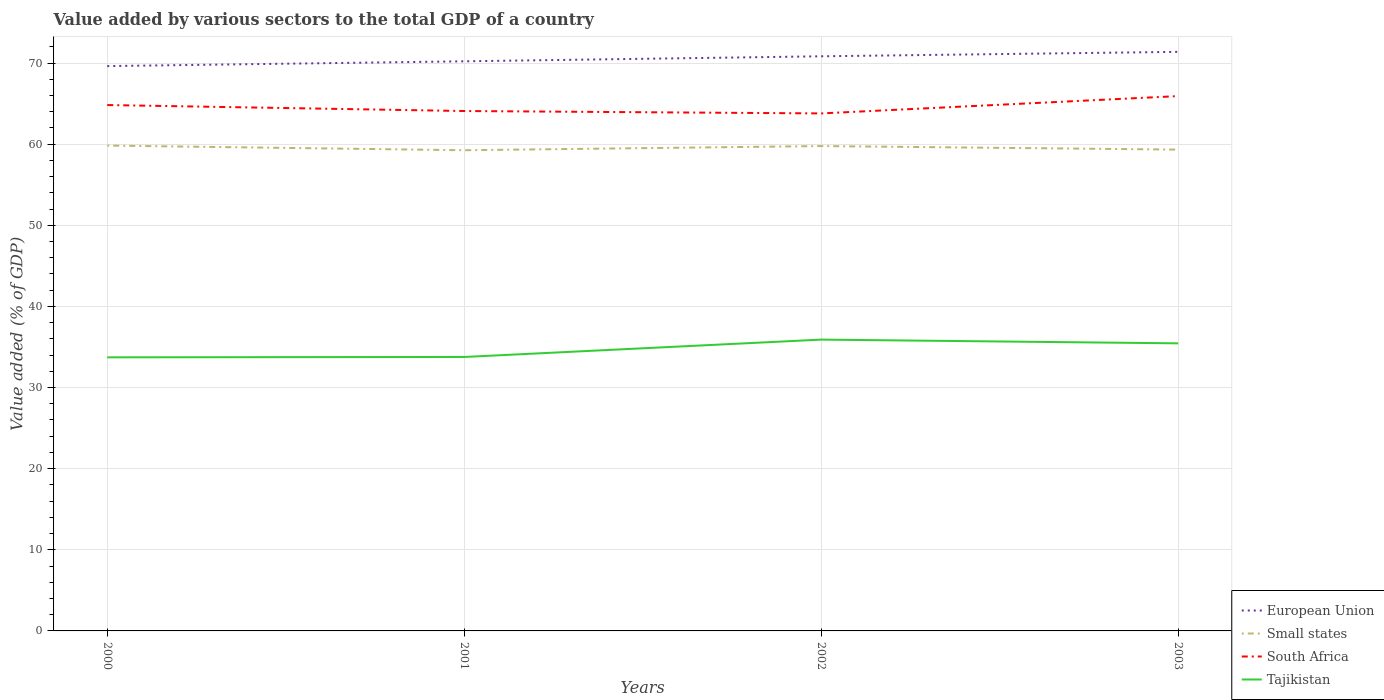How many different coloured lines are there?
Provide a short and direct response. 4. Does the line corresponding to Tajikistan intersect with the line corresponding to European Union?
Make the answer very short. No. Across all years, what is the maximum value added by various sectors to the total GDP in Small states?
Your answer should be compact. 59.25. What is the total value added by various sectors to the total GDP in European Union in the graph?
Ensure brevity in your answer.  -0.62. What is the difference between the highest and the second highest value added by various sectors to the total GDP in Tajikistan?
Provide a short and direct response. 2.18. What is the difference between the highest and the lowest value added by various sectors to the total GDP in European Union?
Offer a terse response. 2. Is the value added by various sectors to the total GDP in South Africa strictly greater than the value added by various sectors to the total GDP in Small states over the years?
Provide a short and direct response. No. How many years are there in the graph?
Provide a succinct answer. 4. What is the difference between two consecutive major ticks on the Y-axis?
Your answer should be compact. 10. Are the values on the major ticks of Y-axis written in scientific E-notation?
Your answer should be very brief. No. How many legend labels are there?
Offer a very short reply. 4. How are the legend labels stacked?
Keep it short and to the point. Vertical. What is the title of the graph?
Offer a terse response. Value added by various sectors to the total GDP of a country. Does "Iceland" appear as one of the legend labels in the graph?
Make the answer very short. No. What is the label or title of the X-axis?
Ensure brevity in your answer.  Years. What is the label or title of the Y-axis?
Your answer should be very brief. Value added (% of GDP). What is the Value added (% of GDP) in European Union in 2000?
Make the answer very short. 69.62. What is the Value added (% of GDP) of Small states in 2000?
Your response must be concise. 59.83. What is the Value added (% of GDP) of South Africa in 2000?
Make the answer very short. 64.82. What is the Value added (% of GDP) in Tajikistan in 2000?
Your answer should be compact. 33.72. What is the Value added (% of GDP) in European Union in 2001?
Make the answer very short. 70.21. What is the Value added (% of GDP) in Small states in 2001?
Ensure brevity in your answer.  59.25. What is the Value added (% of GDP) of South Africa in 2001?
Provide a short and direct response. 64.08. What is the Value added (% of GDP) in Tajikistan in 2001?
Keep it short and to the point. 33.77. What is the Value added (% of GDP) of European Union in 2002?
Your answer should be very brief. 70.83. What is the Value added (% of GDP) of Small states in 2002?
Your answer should be compact. 59.76. What is the Value added (% of GDP) of South Africa in 2002?
Provide a short and direct response. 63.79. What is the Value added (% of GDP) in Tajikistan in 2002?
Your response must be concise. 35.91. What is the Value added (% of GDP) of European Union in 2003?
Give a very brief answer. 71.38. What is the Value added (% of GDP) of Small states in 2003?
Make the answer very short. 59.33. What is the Value added (% of GDP) of South Africa in 2003?
Your answer should be very brief. 65.92. What is the Value added (% of GDP) of Tajikistan in 2003?
Provide a succinct answer. 35.45. Across all years, what is the maximum Value added (% of GDP) in European Union?
Provide a short and direct response. 71.38. Across all years, what is the maximum Value added (% of GDP) in Small states?
Offer a very short reply. 59.83. Across all years, what is the maximum Value added (% of GDP) in South Africa?
Your response must be concise. 65.92. Across all years, what is the maximum Value added (% of GDP) of Tajikistan?
Give a very brief answer. 35.91. Across all years, what is the minimum Value added (% of GDP) of European Union?
Your response must be concise. 69.62. Across all years, what is the minimum Value added (% of GDP) in Small states?
Your response must be concise. 59.25. Across all years, what is the minimum Value added (% of GDP) in South Africa?
Provide a succinct answer. 63.79. Across all years, what is the minimum Value added (% of GDP) of Tajikistan?
Ensure brevity in your answer.  33.72. What is the total Value added (% of GDP) in European Union in the graph?
Give a very brief answer. 282.04. What is the total Value added (% of GDP) of Small states in the graph?
Offer a terse response. 238.17. What is the total Value added (% of GDP) in South Africa in the graph?
Your response must be concise. 258.61. What is the total Value added (% of GDP) of Tajikistan in the graph?
Provide a short and direct response. 138.84. What is the difference between the Value added (% of GDP) of European Union in 2000 and that in 2001?
Give a very brief answer. -0.59. What is the difference between the Value added (% of GDP) in Small states in 2000 and that in 2001?
Ensure brevity in your answer.  0.58. What is the difference between the Value added (% of GDP) in South Africa in 2000 and that in 2001?
Ensure brevity in your answer.  0.74. What is the difference between the Value added (% of GDP) of Tajikistan in 2000 and that in 2001?
Provide a succinct answer. -0.04. What is the difference between the Value added (% of GDP) in European Union in 2000 and that in 2002?
Your answer should be compact. -1.21. What is the difference between the Value added (% of GDP) in Small states in 2000 and that in 2002?
Provide a succinct answer. 0.06. What is the difference between the Value added (% of GDP) of South Africa in 2000 and that in 2002?
Your answer should be very brief. 1.03. What is the difference between the Value added (% of GDP) in Tajikistan in 2000 and that in 2002?
Your response must be concise. -2.18. What is the difference between the Value added (% of GDP) of European Union in 2000 and that in 2003?
Keep it short and to the point. -1.75. What is the difference between the Value added (% of GDP) of South Africa in 2000 and that in 2003?
Offer a terse response. -1.1. What is the difference between the Value added (% of GDP) in Tajikistan in 2000 and that in 2003?
Your response must be concise. -1.72. What is the difference between the Value added (% of GDP) of European Union in 2001 and that in 2002?
Ensure brevity in your answer.  -0.62. What is the difference between the Value added (% of GDP) in Small states in 2001 and that in 2002?
Ensure brevity in your answer.  -0.52. What is the difference between the Value added (% of GDP) in South Africa in 2001 and that in 2002?
Your answer should be compact. 0.29. What is the difference between the Value added (% of GDP) of Tajikistan in 2001 and that in 2002?
Your answer should be very brief. -2.14. What is the difference between the Value added (% of GDP) of European Union in 2001 and that in 2003?
Offer a very short reply. -1.17. What is the difference between the Value added (% of GDP) of Small states in 2001 and that in 2003?
Offer a terse response. -0.08. What is the difference between the Value added (% of GDP) of South Africa in 2001 and that in 2003?
Offer a very short reply. -1.84. What is the difference between the Value added (% of GDP) of Tajikistan in 2001 and that in 2003?
Offer a very short reply. -1.68. What is the difference between the Value added (% of GDP) in European Union in 2002 and that in 2003?
Your answer should be compact. -0.55. What is the difference between the Value added (% of GDP) of Small states in 2002 and that in 2003?
Your answer should be very brief. 0.44. What is the difference between the Value added (% of GDP) in South Africa in 2002 and that in 2003?
Make the answer very short. -2.14. What is the difference between the Value added (% of GDP) in Tajikistan in 2002 and that in 2003?
Provide a short and direct response. 0.46. What is the difference between the Value added (% of GDP) of European Union in 2000 and the Value added (% of GDP) of Small states in 2001?
Provide a succinct answer. 10.37. What is the difference between the Value added (% of GDP) in European Union in 2000 and the Value added (% of GDP) in South Africa in 2001?
Make the answer very short. 5.54. What is the difference between the Value added (% of GDP) of European Union in 2000 and the Value added (% of GDP) of Tajikistan in 2001?
Give a very brief answer. 35.85. What is the difference between the Value added (% of GDP) of Small states in 2000 and the Value added (% of GDP) of South Africa in 2001?
Your answer should be compact. -4.26. What is the difference between the Value added (% of GDP) of Small states in 2000 and the Value added (% of GDP) of Tajikistan in 2001?
Keep it short and to the point. 26.06. What is the difference between the Value added (% of GDP) in South Africa in 2000 and the Value added (% of GDP) in Tajikistan in 2001?
Keep it short and to the point. 31.05. What is the difference between the Value added (% of GDP) of European Union in 2000 and the Value added (% of GDP) of Small states in 2002?
Ensure brevity in your answer.  9.86. What is the difference between the Value added (% of GDP) of European Union in 2000 and the Value added (% of GDP) of South Africa in 2002?
Offer a terse response. 5.83. What is the difference between the Value added (% of GDP) in European Union in 2000 and the Value added (% of GDP) in Tajikistan in 2002?
Your response must be concise. 33.71. What is the difference between the Value added (% of GDP) of Small states in 2000 and the Value added (% of GDP) of South Africa in 2002?
Keep it short and to the point. -3.96. What is the difference between the Value added (% of GDP) of Small states in 2000 and the Value added (% of GDP) of Tajikistan in 2002?
Your response must be concise. 23.92. What is the difference between the Value added (% of GDP) of South Africa in 2000 and the Value added (% of GDP) of Tajikistan in 2002?
Your answer should be very brief. 28.91. What is the difference between the Value added (% of GDP) in European Union in 2000 and the Value added (% of GDP) in Small states in 2003?
Give a very brief answer. 10.3. What is the difference between the Value added (% of GDP) of European Union in 2000 and the Value added (% of GDP) of South Africa in 2003?
Provide a short and direct response. 3.7. What is the difference between the Value added (% of GDP) in European Union in 2000 and the Value added (% of GDP) in Tajikistan in 2003?
Your answer should be very brief. 34.17. What is the difference between the Value added (% of GDP) in Small states in 2000 and the Value added (% of GDP) in South Africa in 2003?
Keep it short and to the point. -6.1. What is the difference between the Value added (% of GDP) of Small states in 2000 and the Value added (% of GDP) of Tajikistan in 2003?
Keep it short and to the point. 24.38. What is the difference between the Value added (% of GDP) in South Africa in 2000 and the Value added (% of GDP) in Tajikistan in 2003?
Provide a succinct answer. 29.37. What is the difference between the Value added (% of GDP) of European Union in 2001 and the Value added (% of GDP) of Small states in 2002?
Your response must be concise. 10.45. What is the difference between the Value added (% of GDP) of European Union in 2001 and the Value added (% of GDP) of South Africa in 2002?
Provide a succinct answer. 6.42. What is the difference between the Value added (% of GDP) of European Union in 2001 and the Value added (% of GDP) of Tajikistan in 2002?
Offer a very short reply. 34.3. What is the difference between the Value added (% of GDP) in Small states in 2001 and the Value added (% of GDP) in South Africa in 2002?
Offer a very short reply. -4.54. What is the difference between the Value added (% of GDP) in Small states in 2001 and the Value added (% of GDP) in Tajikistan in 2002?
Make the answer very short. 23.34. What is the difference between the Value added (% of GDP) in South Africa in 2001 and the Value added (% of GDP) in Tajikistan in 2002?
Make the answer very short. 28.17. What is the difference between the Value added (% of GDP) of European Union in 2001 and the Value added (% of GDP) of Small states in 2003?
Provide a short and direct response. 10.88. What is the difference between the Value added (% of GDP) of European Union in 2001 and the Value added (% of GDP) of South Africa in 2003?
Keep it short and to the point. 4.29. What is the difference between the Value added (% of GDP) of European Union in 2001 and the Value added (% of GDP) of Tajikistan in 2003?
Ensure brevity in your answer.  34.76. What is the difference between the Value added (% of GDP) in Small states in 2001 and the Value added (% of GDP) in South Africa in 2003?
Ensure brevity in your answer.  -6.67. What is the difference between the Value added (% of GDP) of Small states in 2001 and the Value added (% of GDP) of Tajikistan in 2003?
Give a very brief answer. 23.8. What is the difference between the Value added (% of GDP) of South Africa in 2001 and the Value added (% of GDP) of Tajikistan in 2003?
Ensure brevity in your answer.  28.64. What is the difference between the Value added (% of GDP) in European Union in 2002 and the Value added (% of GDP) in Small states in 2003?
Keep it short and to the point. 11.5. What is the difference between the Value added (% of GDP) of European Union in 2002 and the Value added (% of GDP) of South Africa in 2003?
Keep it short and to the point. 4.91. What is the difference between the Value added (% of GDP) of European Union in 2002 and the Value added (% of GDP) of Tajikistan in 2003?
Ensure brevity in your answer.  35.38. What is the difference between the Value added (% of GDP) in Small states in 2002 and the Value added (% of GDP) in South Africa in 2003?
Keep it short and to the point. -6.16. What is the difference between the Value added (% of GDP) of Small states in 2002 and the Value added (% of GDP) of Tajikistan in 2003?
Provide a short and direct response. 24.32. What is the difference between the Value added (% of GDP) of South Africa in 2002 and the Value added (% of GDP) of Tajikistan in 2003?
Provide a short and direct response. 28.34. What is the average Value added (% of GDP) in European Union per year?
Provide a succinct answer. 70.51. What is the average Value added (% of GDP) of Small states per year?
Offer a terse response. 59.54. What is the average Value added (% of GDP) in South Africa per year?
Your answer should be very brief. 64.65. What is the average Value added (% of GDP) of Tajikistan per year?
Your response must be concise. 34.71. In the year 2000, what is the difference between the Value added (% of GDP) of European Union and Value added (% of GDP) of Small states?
Offer a very short reply. 9.8. In the year 2000, what is the difference between the Value added (% of GDP) in European Union and Value added (% of GDP) in South Africa?
Offer a terse response. 4.8. In the year 2000, what is the difference between the Value added (% of GDP) in European Union and Value added (% of GDP) in Tajikistan?
Your response must be concise. 35.9. In the year 2000, what is the difference between the Value added (% of GDP) in Small states and Value added (% of GDP) in South Africa?
Give a very brief answer. -4.99. In the year 2000, what is the difference between the Value added (% of GDP) in Small states and Value added (% of GDP) in Tajikistan?
Ensure brevity in your answer.  26.1. In the year 2000, what is the difference between the Value added (% of GDP) of South Africa and Value added (% of GDP) of Tajikistan?
Give a very brief answer. 31.1. In the year 2001, what is the difference between the Value added (% of GDP) of European Union and Value added (% of GDP) of Small states?
Your answer should be very brief. 10.96. In the year 2001, what is the difference between the Value added (% of GDP) of European Union and Value added (% of GDP) of South Africa?
Your answer should be compact. 6.13. In the year 2001, what is the difference between the Value added (% of GDP) of European Union and Value added (% of GDP) of Tajikistan?
Give a very brief answer. 36.44. In the year 2001, what is the difference between the Value added (% of GDP) of Small states and Value added (% of GDP) of South Africa?
Your answer should be very brief. -4.83. In the year 2001, what is the difference between the Value added (% of GDP) in Small states and Value added (% of GDP) in Tajikistan?
Your response must be concise. 25.48. In the year 2001, what is the difference between the Value added (% of GDP) of South Africa and Value added (% of GDP) of Tajikistan?
Offer a terse response. 30.32. In the year 2002, what is the difference between the Value added (% of GDP) of European Union and Value added (% of GDP) of Small states?
Offer a very short reply. 11.06. In the year 2002, what is the difference between the Value added (% of GDP) of European Union and Value added (% of GDP) of South Africa?
Make the answer very short. 7.04. In the year 2002, what is the difference between the Value added (% of GDP) of European Union and Value added (% of GDP) of Tajikistan?
Keep it short and to the point. 34.92. In the year 2002, what is the difference between the Value added (% of GDP) in Small states and Value added (% of GDP) in South Africa?
Give a very brief answer. -4.02. In the year 2002, what is the difference between the Value added (% of GDP) in Small states and Value added (% of GDP) in Tajikistan?
Provide a succinct answer. 23.86. In the year 2002, what is the difference between the Value added (% of GDP) in South Africa and Value added (% of GDP) in Tajikistan?
Keep it short and to the point. 27.88. In the year 2003, what is the difference between the Value added (% of GDP) of European Union and Value added (% of GDP) of Small states?
Provide a succinct answer. 12.05. In the year 2003, what is the difference between the Value added (% of GDP) of European Union and Value added (% of GDP) of South Africa?
Give a very brief answer. 5.45. In the year 2003, what is the difference between the Value added (% of GDP) in European Union and Value added (% of GDP) in Tajikistan?
Ensure brevity in your answer.  35.93. In the year 2003, what is the difference between the Value added (% of GDP) in Small states and Value added (% of GDP) in South Africa?
Provide a succinct answer. -6.6. In the year 2003, what is the difference between the Value added (% of GDP) in Small states and Value added (% of GDP) in Tajikistan?
Offer a terse response. 23.88. In the year 2003, what is the difference between the Value added (% of GDP) in South Africa and Value added (% of GDP) in Tajikistan?
Give a very brief answer. 30.48. What is the ratio of the Value added (% of GDP) in Small states in 2000 to that in 2001?
Give a very brief answer. 1.01. What is the ratio of the Value added (% of GDP) in South Africa in 2000 to that in 2001?
Provide a short and direct response. 1.01. What is the ratio of the Value added (% of GDP) of South Africa in 2000 to that in 2002?
Your response must be concise. 1.02. What is the ratio of the Value added (% of GDP) in Tajikistan in 2000 to that in 2002?
Keep it short and to the point. 0.94. What is the ratio of the Value added (% of GDP) in European Union in 2000 to that in 2003?
Your response must be concise. 0.98. What is the ratio of the Value added (% of GDP) in Small states in 2000 to that in 2003?
Your response must be concise. 1.01. What is the ratio of the Value added (% of GDP) of South Africa in 2000 to that in 2003?
Your answer should be compact. 0.98. What is the ratio of the Value added (% of GDP) in Tajikistan in 2000 to that in 2003?
Your response must be concise. 0.95. What is the ratio of the Value added (% of GDP) of European Union in 2001 to that in 2002?
Ensure brevity in your answer.  0.99. What is the ratio of the Value added (% of GDP) in Tajikistan in 2001 to that in 2002?
Ensure brevity in your answer.  0.94. What is the ratio of the Value added (% of GDP) in European Union in 2001 to that in 2003?
Ensure brevity in your answer.  0.98. What is the ratio of the Value added (% of GDP) in Small states in 2001 to that in 2003?
Provide a short and direct response. 1. What is the ratio of the Value added (% of GDP) of South Africa in 2001 to that in 2003?
Provide a succinct answer. 0.97. What is the ratio of the Value added (% of GDP) in Tajikistan in 2001 to that in 2003?
Your answer should be very brief. 0.95. What is the ratio of the Value added (% of GDP) of European Union in 2002 to that in 2003?
Your answer should be compact. 0.99. What is the ratio of the Value added (% of GDP) of Small states in 2002 to that in 2003?
Provide a succinct answer. 1.01. What is the ratio of the Value added (% of GDP) of South Africa in 2002 to that in 2003?
Keep it short and to the point. 0.97. What is the difference between the highest and the second highest Value added (% of GDP) of European Union?
Provide a short and direct response. 0.55. What is the difference between the highest and the second highest Value added (% of GDP) of Small states?
Provide a succinct answer. 0.06. What is the difference between the highest and the second highest Value added (% of GDP) of South Africa?
Make the answer very short. 1.1. What is the difference between the highest and the second highest Value added (% of GDP) in Tajikistan?
Offer a terse response. 0.46. What is the difference between the highest and the lowest Value added (% of GDP) of European Union?
Make the answer very short. 1.75. What is the difference between the highest and the lowest Value added (% of GDP) in Small states?
Keep it short and to the point. 0.58. What is the difference between the highest and the lowest Value added (% of GDP) in South Africa?
Give a very brief answer. 2.14. What is the difference between the highest and the lowest Value added (% of GDP) in Tajikistan?
Provide a succinct answer. 2.18. 